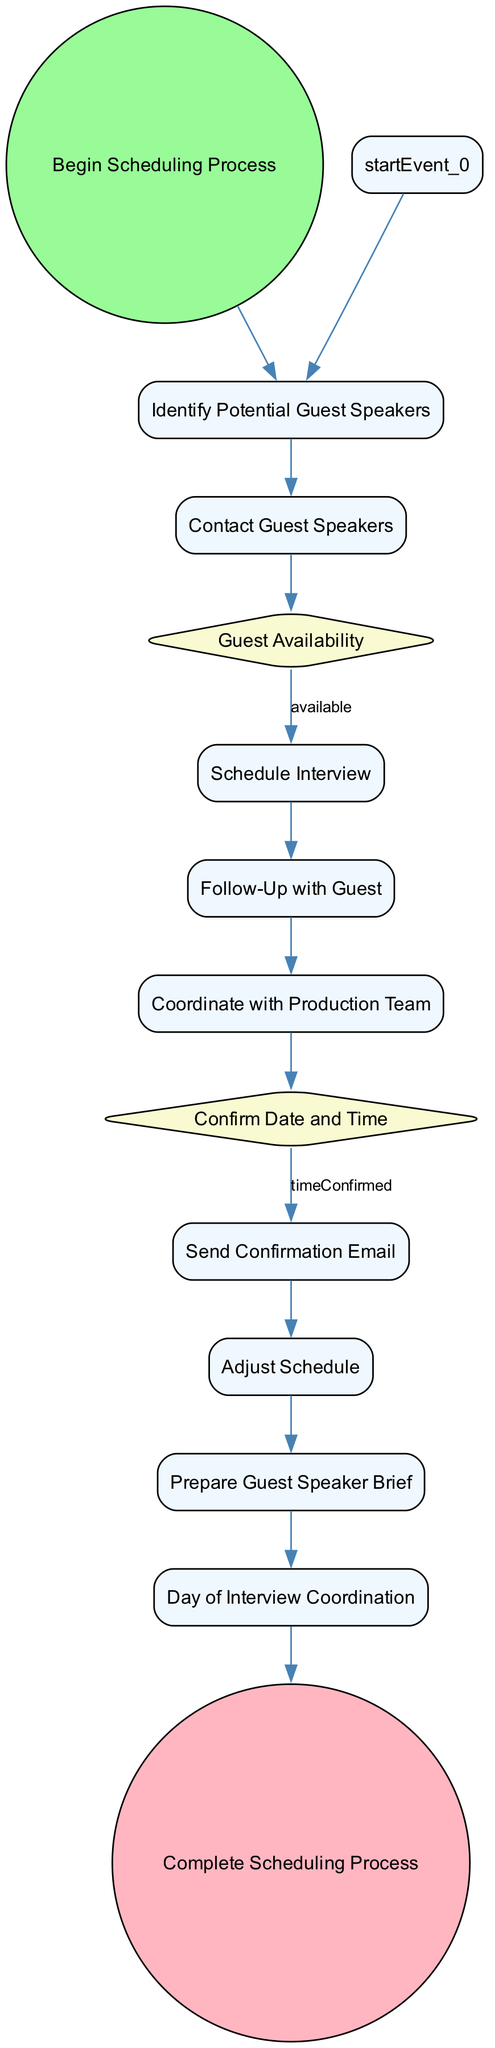What is the first activity in the scheduling process? The first activity node in the diagram is labeled "Identify Potential Guest Speakers," which follows the start event "Begin Scheduling Process."
Answer: Identify Potential Guest Speakers How many decision points are in the diagram? By examining the diagram, there are two decision nodes: "Guest Availability" and "Confirm Date and Time."
Answer: 2 What is the outcome if a guest is unavailable? Following the "Guest Availability" decision node, if a guest is unavailable, the flow proceeds to the "Follow-Up with Guest" activity.
Answer: Follow-Up with Guest What activity happens after sending a confirmation email? After the "Send Confirmation Email" activity, the next activity in the flow is "Prepare Guest Speaker Brief," as depicted in the diagram.
Answer: Prepare Guest Speaker Brief Which node represents the end of the scheduling process? The end event of the scheduling process is marked by the "Complete Scheduling Process" node, which is the last element in the flow.
Answer: Complete Scheduling Process What activity must be completed before day-of coordination? Prior to the "Day of Interview Coordination," the activity "Prepare Guest Speaker Brief" must be completed, as indicated in the flow sequence.
Answer: Prepare Guest Speaker Brief What is the condition for scheduling an interview? An interview can be scheduled when the condition "available" is met, according to the flow that follows the "Guest Availability" decision.
Answer: available What activity follows if the time is not confirmed? If the decision point "Confirm Date and Time" leads to "timeNotConfirmed," the following activity is "Adjust Schedule" according to the subsequent flow.
Answer: Adjust Schedule 